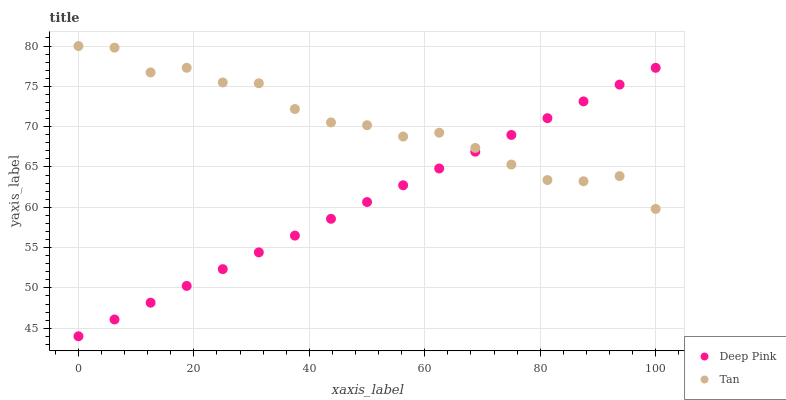Does Deep Pink have the minimum area under the curve?
Answer yes or no. Yes. Does Tan have the maximum area under the curve?
Answer yes or no. Yes. Does Deep Pink have the maximum area under the curve?
Answer yes or no. No. Is Deep Pink the smoothest?
Answer yes or no. Yes. Is Tan the roughest?
Answer yes or no. Yes. Is Deep Pink the roughest?
Answer yes or no. No. Does Deep Pink have the lowest value?
Answer yes or no. Yes. Does Tan have the highest value?
Answer yes or no. Yes. Does Deep Pink have the highest value?
Answer yes or no. No. Does Deep Pink intersect Tan?
Answer yes or no. Yes. Is Deep Pink less than Tan?
Answer yes or no. No. Is Deep Pink greater than Tan?
Answer yes or no. No. 